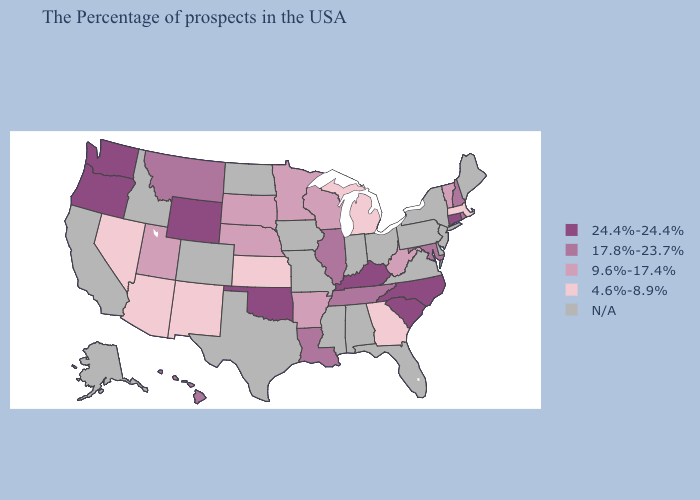Name the states that have a value in the range N/A?
Give a very brief answer. Maine, New York, New Jersey, Delaware, Pennsylvania, Virginia, Ohio, Florida, Indiana, Alabama, Mississippi, Missouri, Iowa, Texas, North Dakota, Colorado, Idaho, California, Alaska. Does the map have missing data?
Quick response, please. Yes. Does Montana have the lowest value in the USA?
Concise answer only. No. Name the states that have a value in the range N/A?
Give a very brief answer. Maine, New York, New Jersey, Delaware, Pennsylvania, Virginia, Ohio, Florida, Indiana, Alabama, Mississippi, Missouri, Iowa, Texas, North Dakota, Colorado, Idaho, California, Alaska. Among the states that border New York , does Connecticut have the highest value?
Short answer required. Yes. What is the lowest value in the USA?
Give a very brief answer. 4.6%-8.9%. Does the map have missing data?
Answer briefly. Yes. Among the states that border Nebraska , does Wyoming have the highest value?
Concise answer only. Yes. Does the first symbol in the legend represent the smallest category?
Concise answer only. No. What is the value of Massachusetts?
Write a very short answer. 4.6%-8.9%. What is the value of California?
Concise answer only. N/A. What is the lowest value in the MidWest?
Quick response, please. 4.6%-8.9%. What is the value of Delaware?
Give a very brief answer. N/A. 